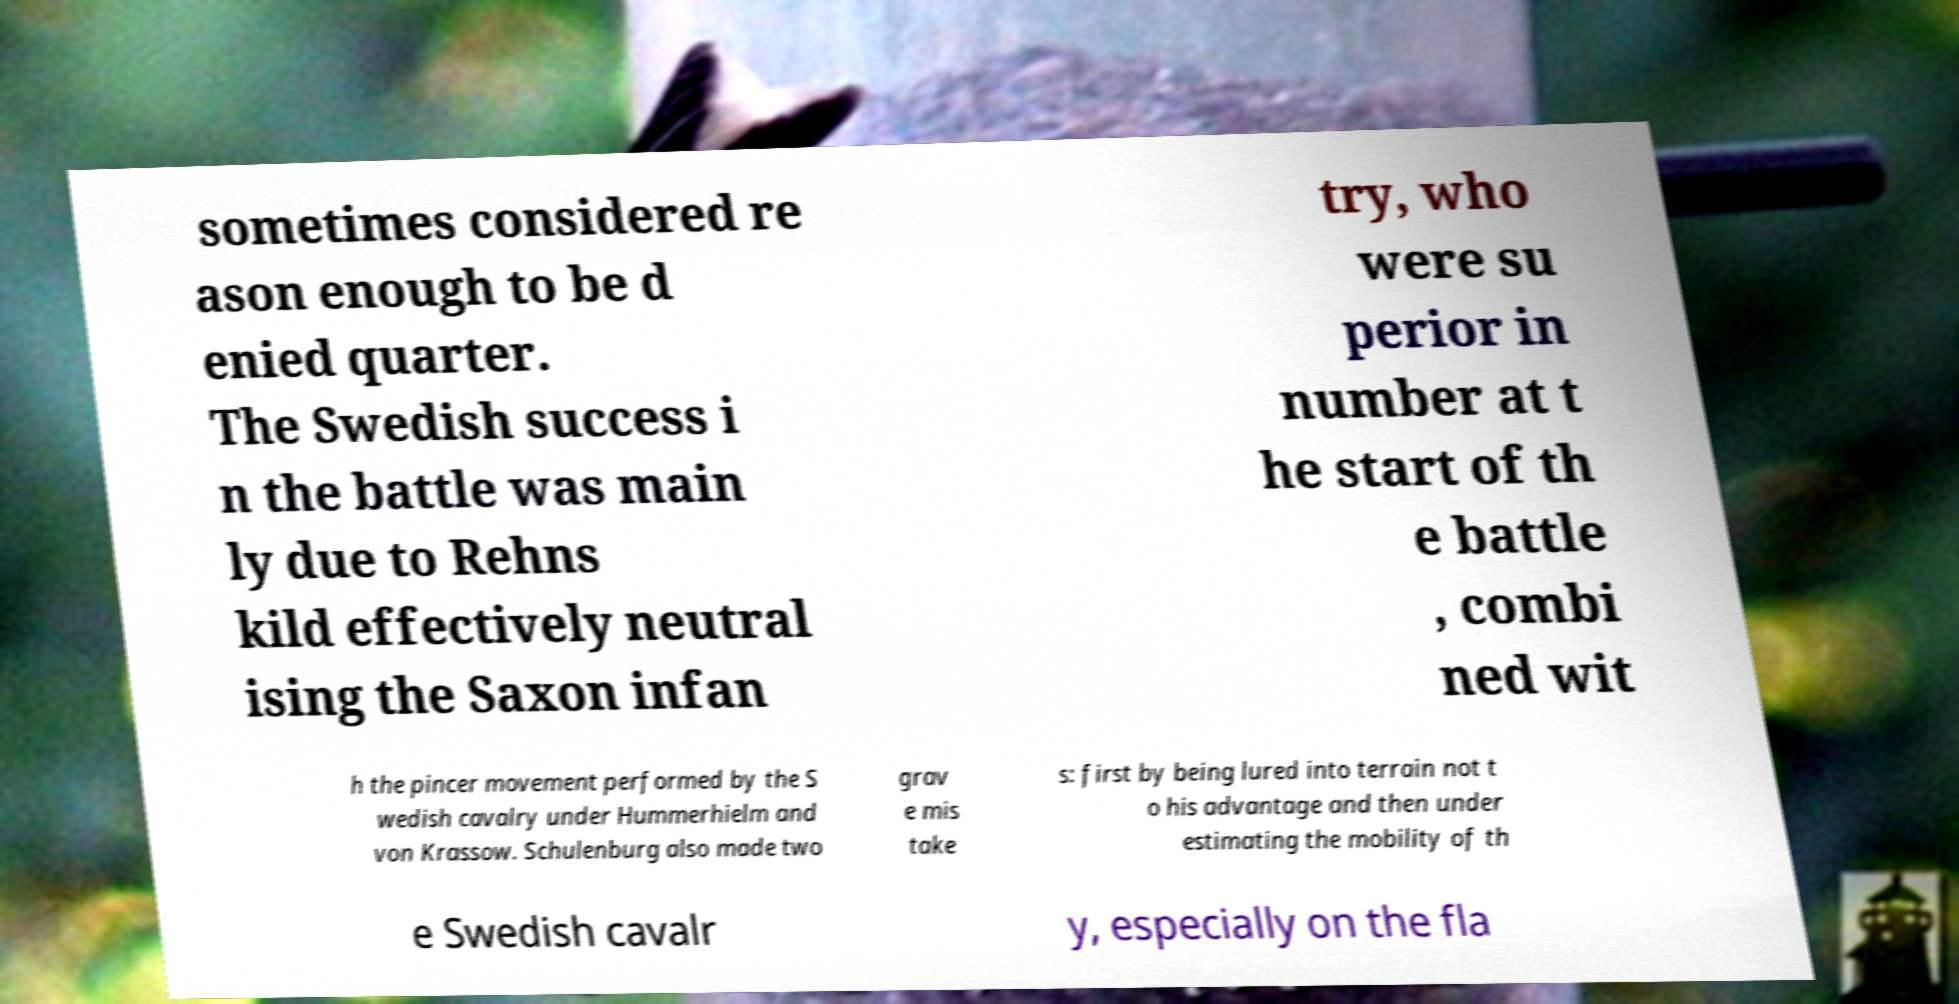Could you extract and type out the text from this image? sometimes considered re ason enough to be d enied quarter. The Swedish success i n the battle was main ly due to Rehns kild effectively neutral ising the Saxon infan try, who were su perior in number at t he start of th e battle , combi ned wit h the pincer movement performed by the S wedish cavalry under Hummerhielm and von Krassow. Schulenburg also made two grav e mis take s: first by being lured into terrain not t o his advantage and then under estimating the mobility of th e Swedish cavalr y, especially on the fla 